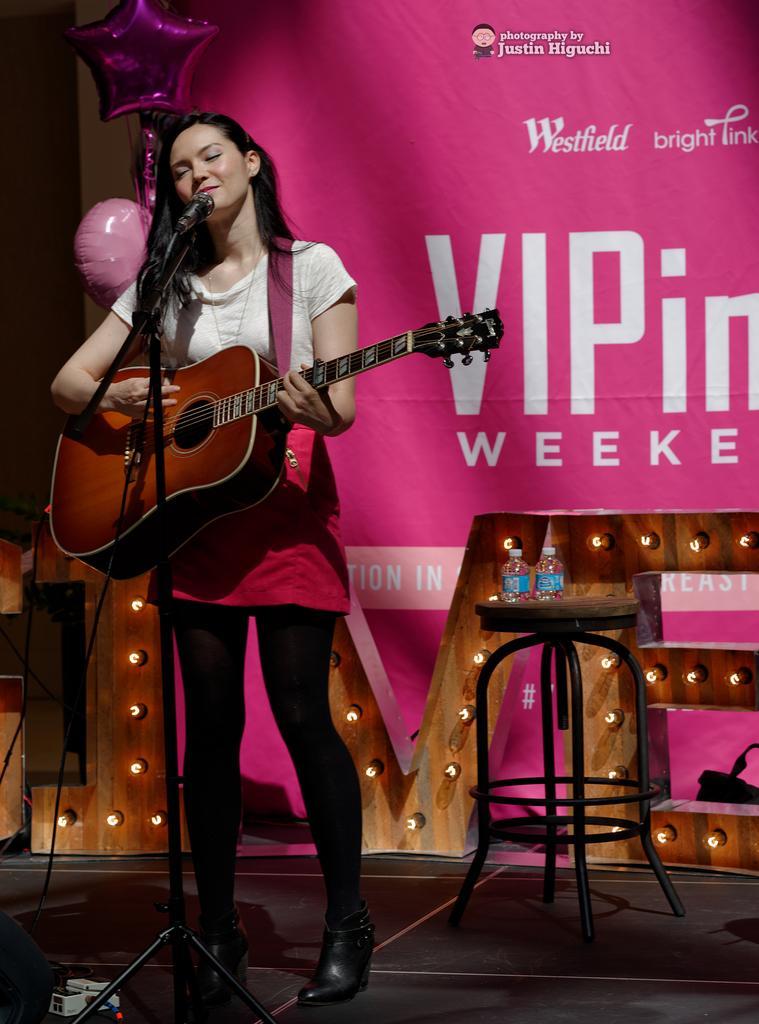Could you give a brief overview of what you see in this image? In this picture we can see a woman who is playing guitar. This is mike. There is table. On the table there are bottles. This is floor. On the background there is a banner and this is balloon. 